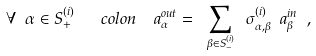Convert formula to latex. <formula><loc_0><loc_0><loc_500><loc_500>\forall \ \alpha \in S _ { + } ^ { ( i ) } \ \ \ c o l o n \ \ a _ { \alpha } ^ { o u t } = \ \sum _ { \beta \in S _ { - } ^ { ( i ) } } \ \sigma ^ { ( i ) } _ { \alpha , \beta } \ a _ { \beta } ^ { i n } \ ,</formula> 